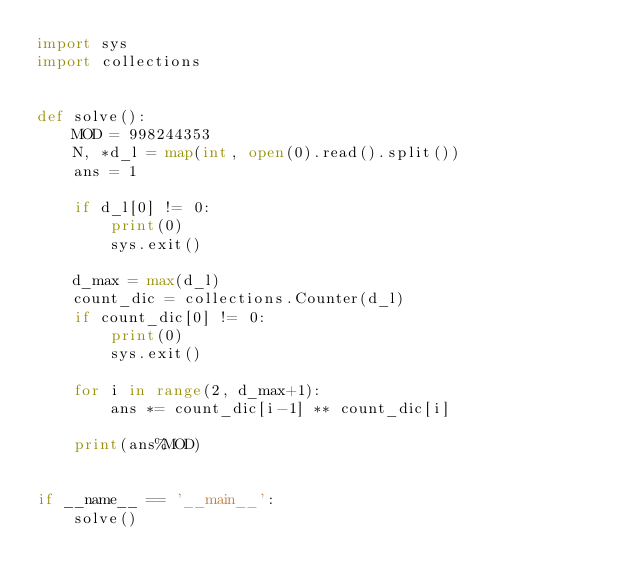<code> <loc_0><loc_0><loc_500><loc_500><_Python_>import sys
import collections


def solve():
    MOD = 998244353
    N, *d_l = map(int, open(0).read().split())
    ans = 1
    
    if d_l[0] != 0:
        print(0)
        sys.exit()
    
    d_max = max(d_l)
    count_dic = collections.Counter(d_l)
    if count_dic[0] != 0:
        print(0)
        sys.exit()
    
    for i in range(2, d_max+1):
        ans *= count_dic[i-1] ** count_dic[i]
    
    print(ans%MOD)


if __name__ == '__main__':
    solve()</code> 